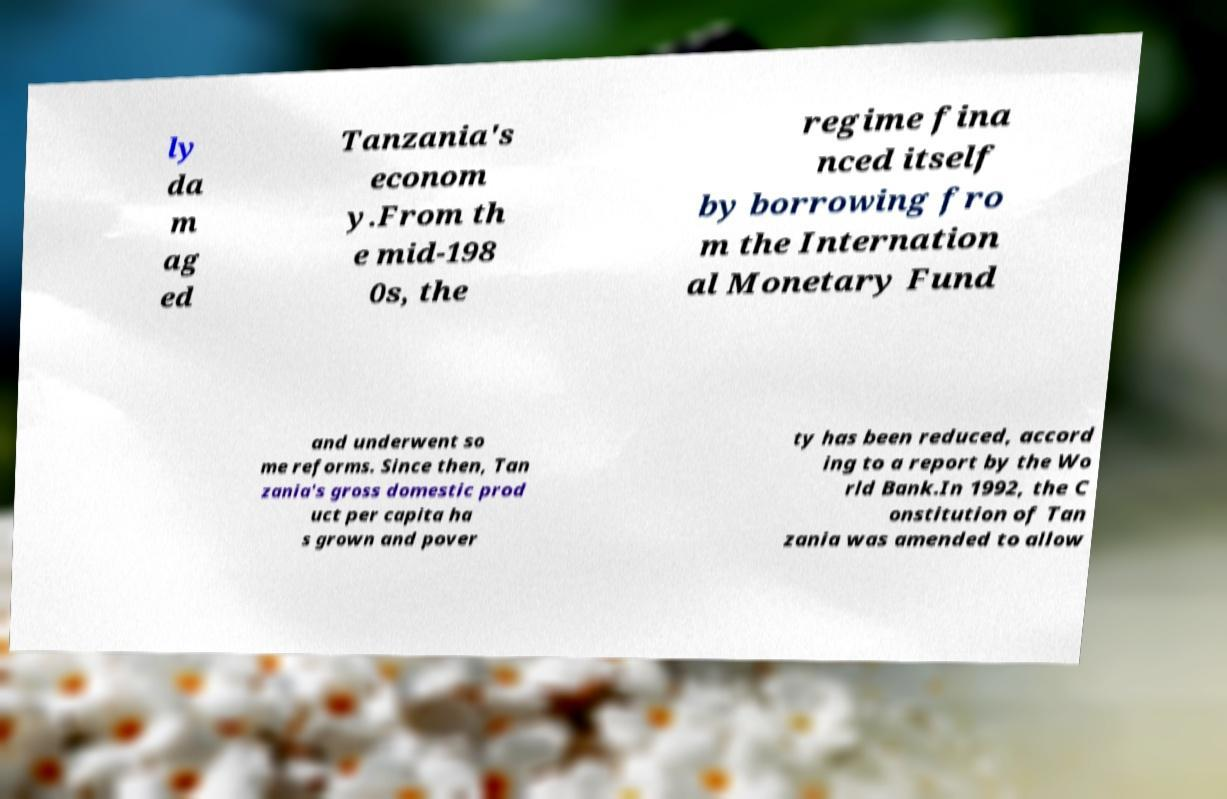There's text embedded in this image that I need extracted. Can you transcribe it verbatim? ly da m ag ed Tanzania's econom y.From th e mid-198 0s, the regime fina nced itself by borrowing fro m the Internation al Monetary Fund and underwent so me reforms. Since then, Tan zania's gross domestic prod uct per capita ha s grown and pover ty has been reduced, accord ing to a report by the Wo rld Bank.In 1992, the C onstitution of Tan zania was amended to allow 